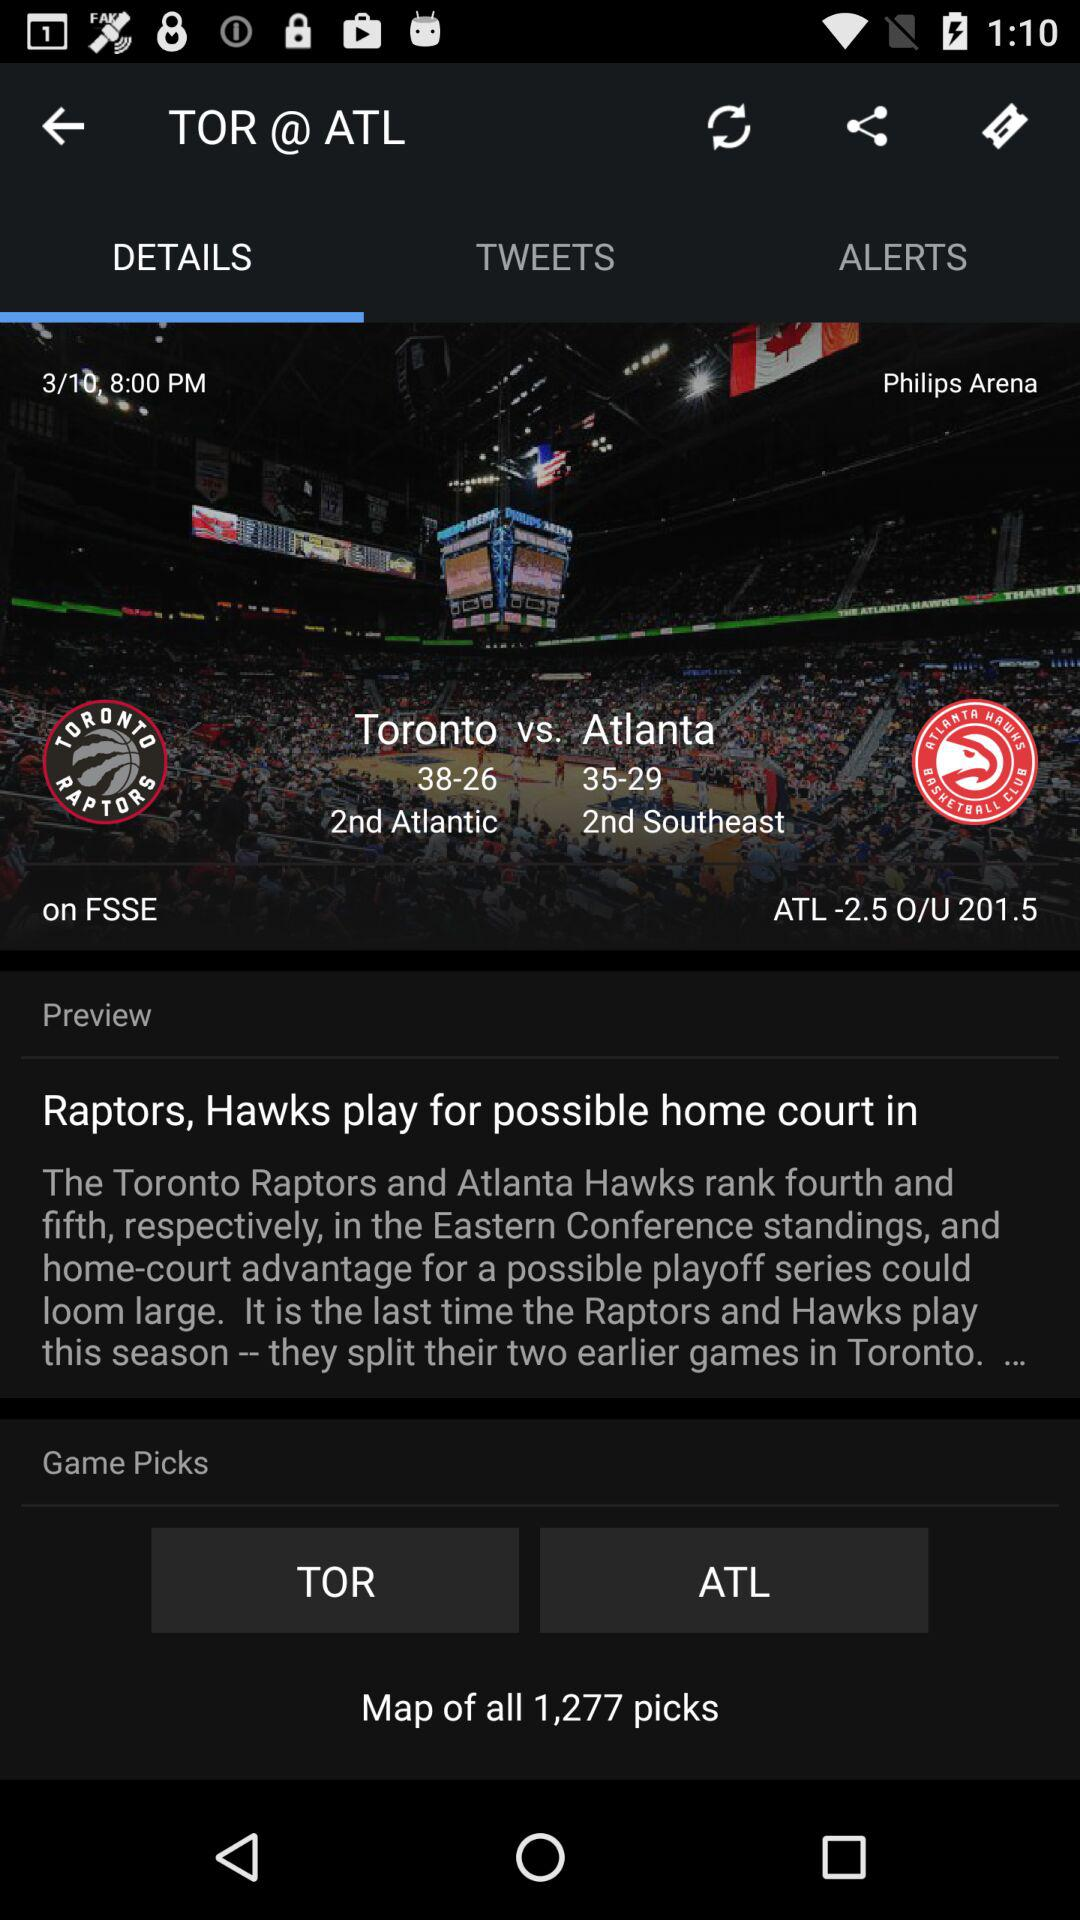What's the conference record of "Toronto" and "Atlanta"? The conference record is "Toronto": 38-26 and "Atlanta": 35-29. 